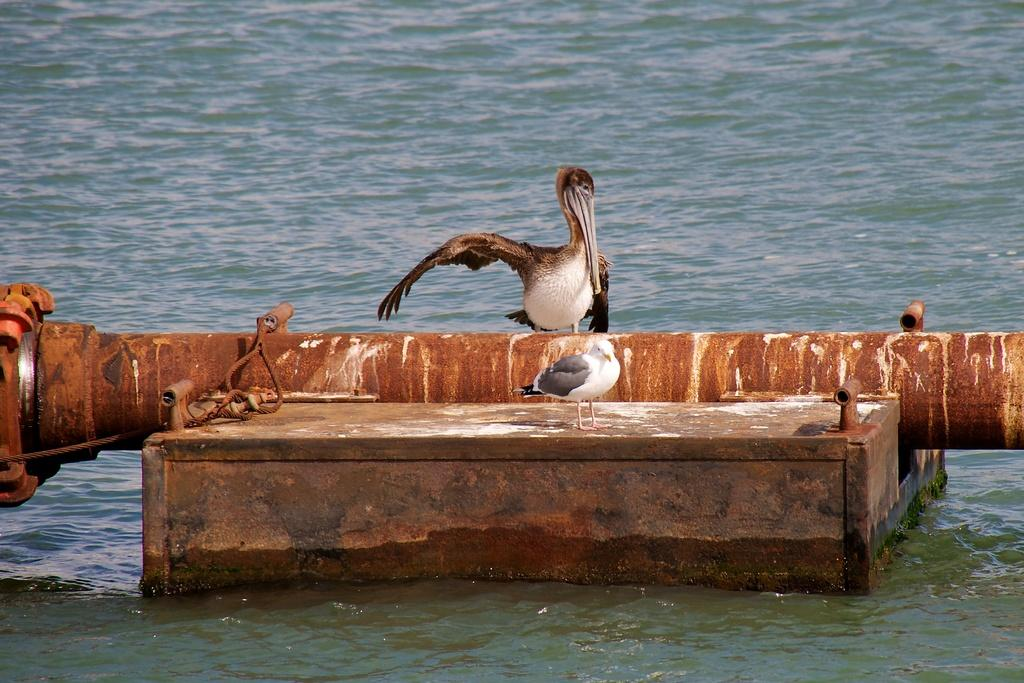What is the main object in the middle of the image? There is a pipe in the middle of the image. What can be seen at the bottom of the image? There is water at the bottom of the image. What animals are present in the image? Two birds are standing in the middle of the image. What type of juice is being served in the image? There is no juice present in the image; it features a pipe, water, and two birds. Who is the representative standing next to the birds in the image? There is no representative present in the image; it only features a pipe, water, and two birds. 